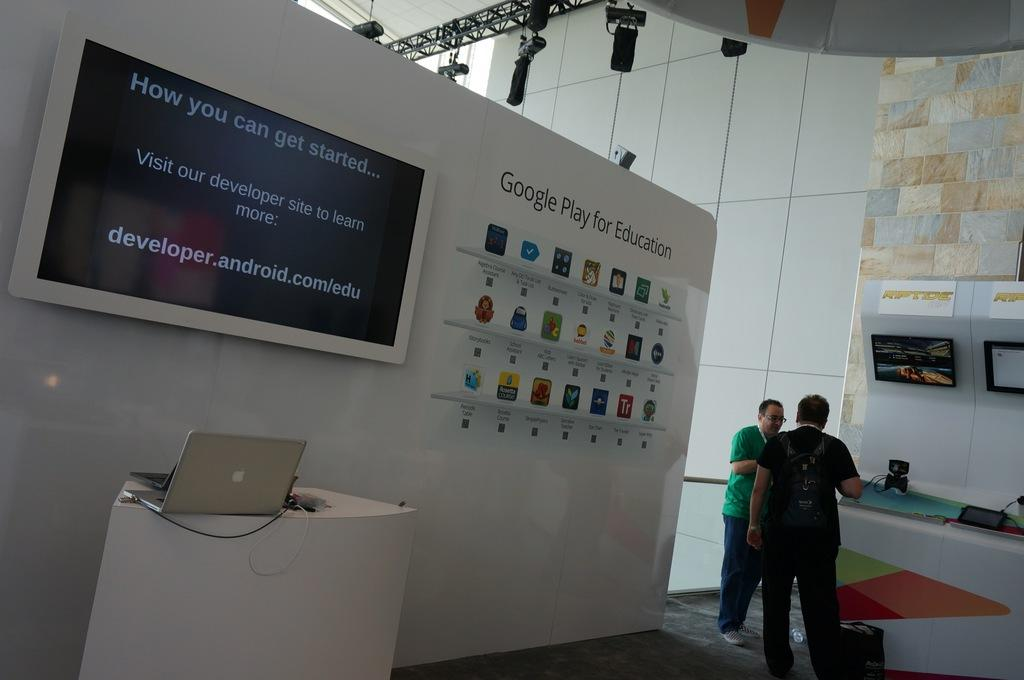What is on the wall in the image? There is a TV on the wall in the image. What is displayed on the TV? There is writing on the TV. Where are the people in the image located? There are two people standing on the right side of the image. What type of food is the porter serving in the image? There is no porter or food present in the image. What meal are the two people eating in the image? There is no meal being eaten in the image; the two people are standing on the right side. 